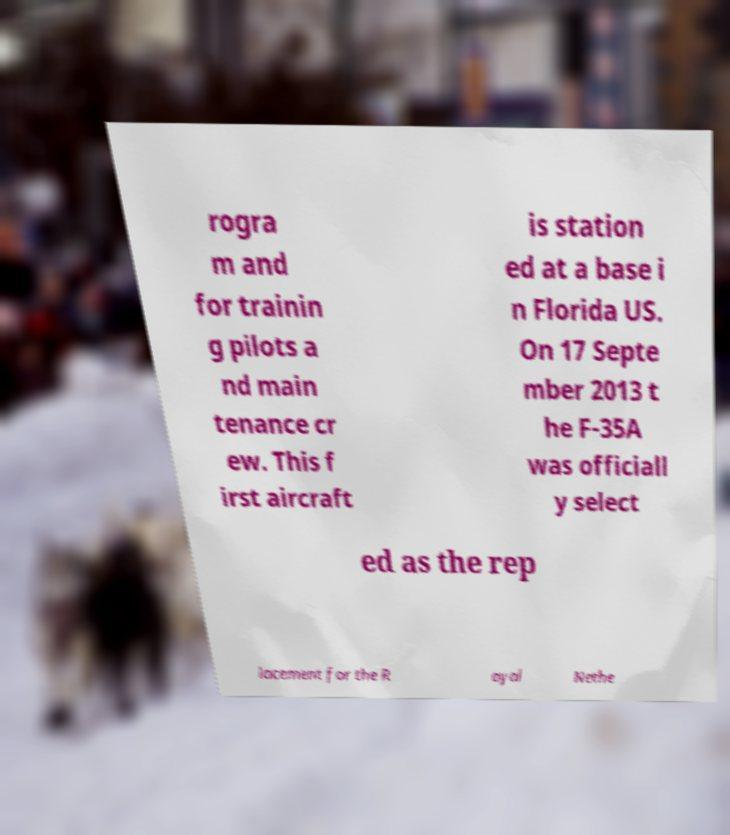Can you accurately transcribe the text from the provided image for me? rogra m and for trainin g pilots a nd main tenance cr ew. This f irst aircraft is station ed at a base i n Florida US. On 17 Septe mber 2013 t he F-35A was officiall y select ed as the rep lacement for the R oyal Nethe 